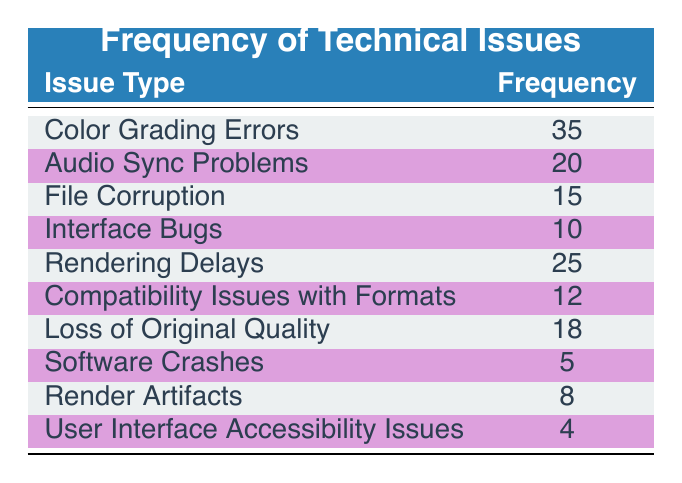What is the highest frequency value reported for any technical issue? The table lists the frequency of various technical issues. By scanning the "Frequency" column, "Color Grading Errors" has the highest frequency, which is 35.
Answer: 35 How many issues have a frequency higher than 15? By reviewing the table, the issues with frequencies above 15 are "Color Grading Errors" (35), "Rendering Delays" (25), "Audio Sync Problems" (20), and "Loss of Original Quality" (18), totaling four issues greater than 15.
Answer: 4 What are the frequencies of "Software Crashes" and "User Interface Accessibility Issues"? From the table, "Software Crashes" has a frequency of 5, and "User Interface Accessibility Issues" has a frequency of 4.
Answer: 5 and 4 What is the total frequency of all reported technical issues? To find the total frequency, sum up all individual frequencies listed: 35 + 20 + 15 + 10 + 25 + 12 + 18 + 5 + 8 + 4 =  152.
Answer: 152 Is there any issue with a frequency less than 5? Looking at the frequency values in the table, the lowest frequency is 4 (for "User Interface Accessibility Issues"), so there are no issues with a frequency less than 5.
Answer: No 